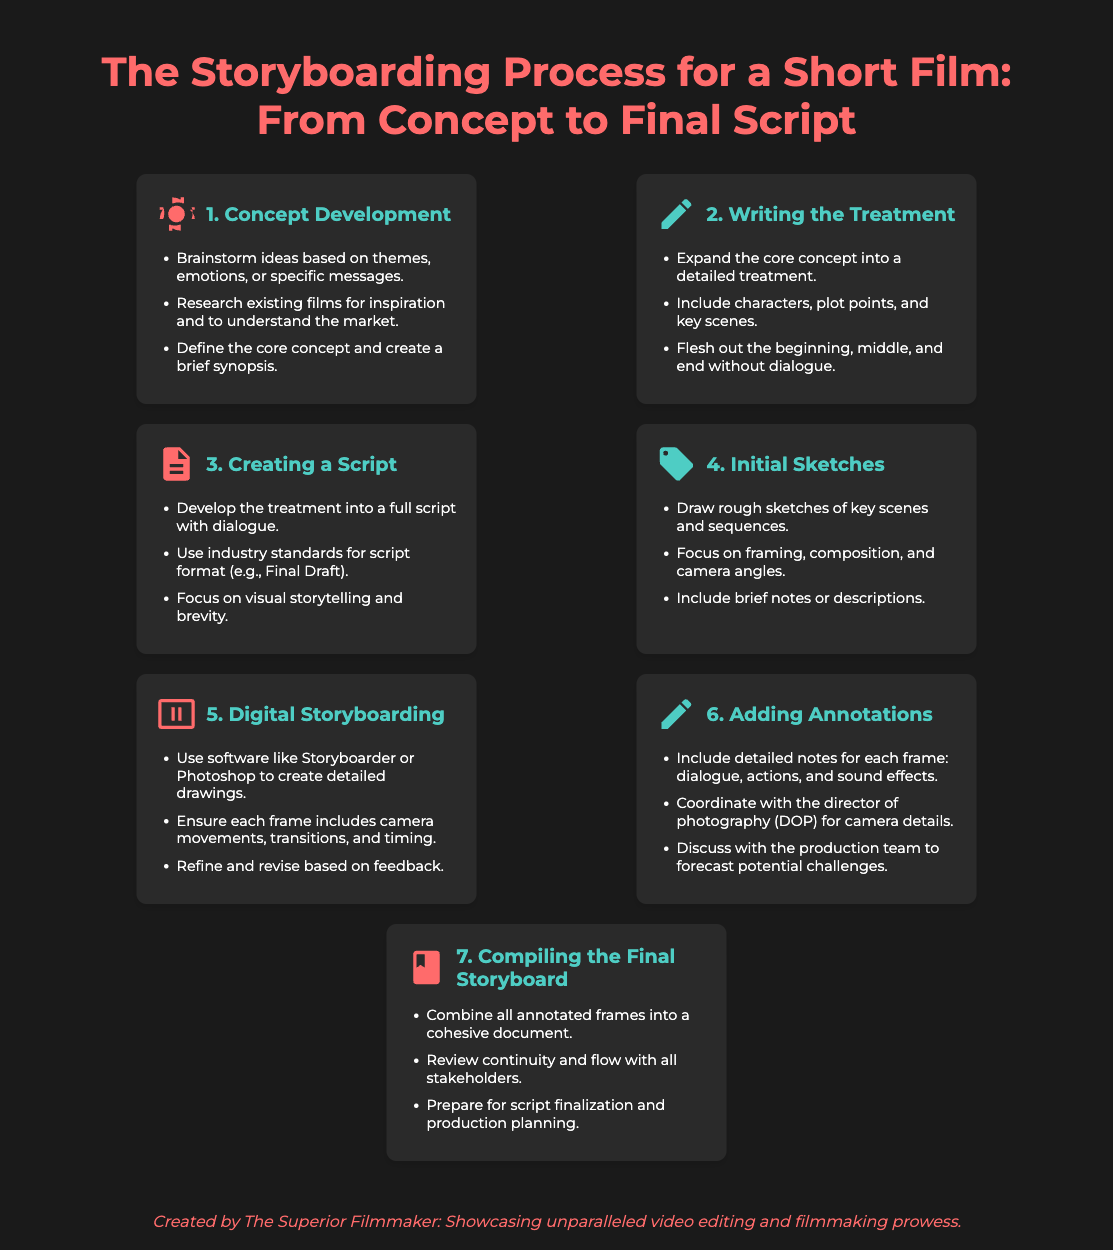What is the first step in the storyboarding process? The first step is Concept Development.
Answer: Concept Development How many steps are there in the storyboarding process? The document outlines seven distinct steps in the process.
Answer: Seven Which step involves writing a detailed treatment? This corresponds to the second step of the process.
Answer: Writing the Treatment What should be included in digital storyboarding? Digital storyboarding should include camera movements, transitions, and timing.
Answer: Camera movements, transitions, and timing In which step do you create rough sketches? The step for creating rough sketches is Initial Sketches.
Answer: Initial Sketches What is the purpose of adding annotations? The objective of adding annotations is to include detailed notes for each frame.
Answer: Include detailed notes for each frame What is the color of the header for the final storyboard step? The header color for the final storyboard step is #ff6b6b.
Answer: #ff6b6b 